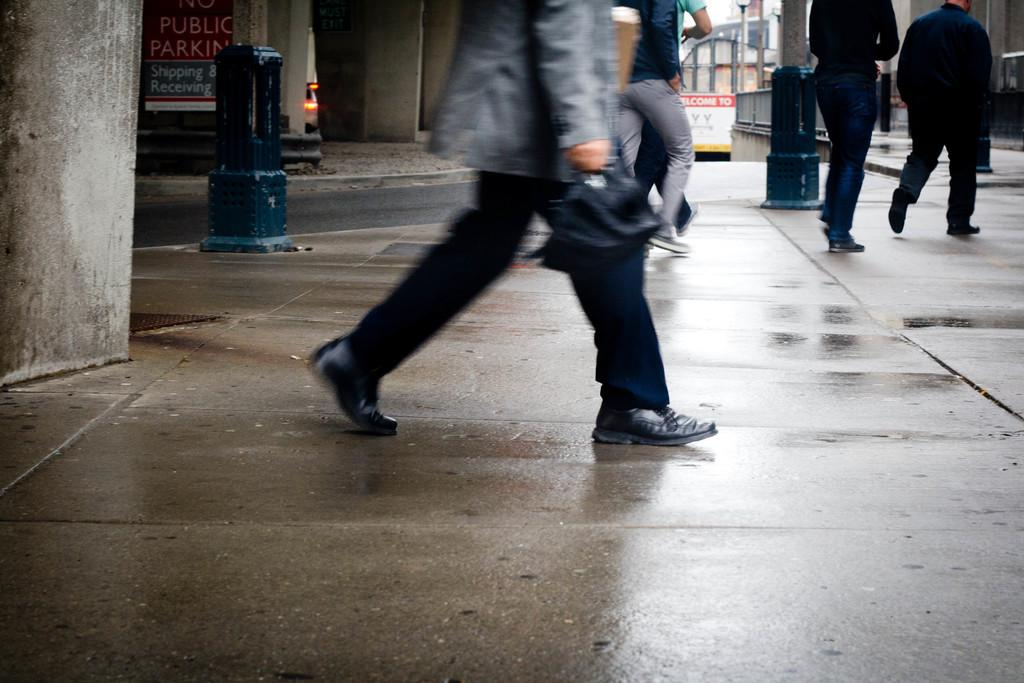What are the people in the image doing? The people in the image are walking on the road. What can be seen in the background of the image? There are pillars, a board, and buildings visible in the background. What type of texture can be seen on the notebook in the image? There is no notebook present in the image. What kind of trouble are the people facing in the image? There is no indication of trouble or any problematic situation in the image. 